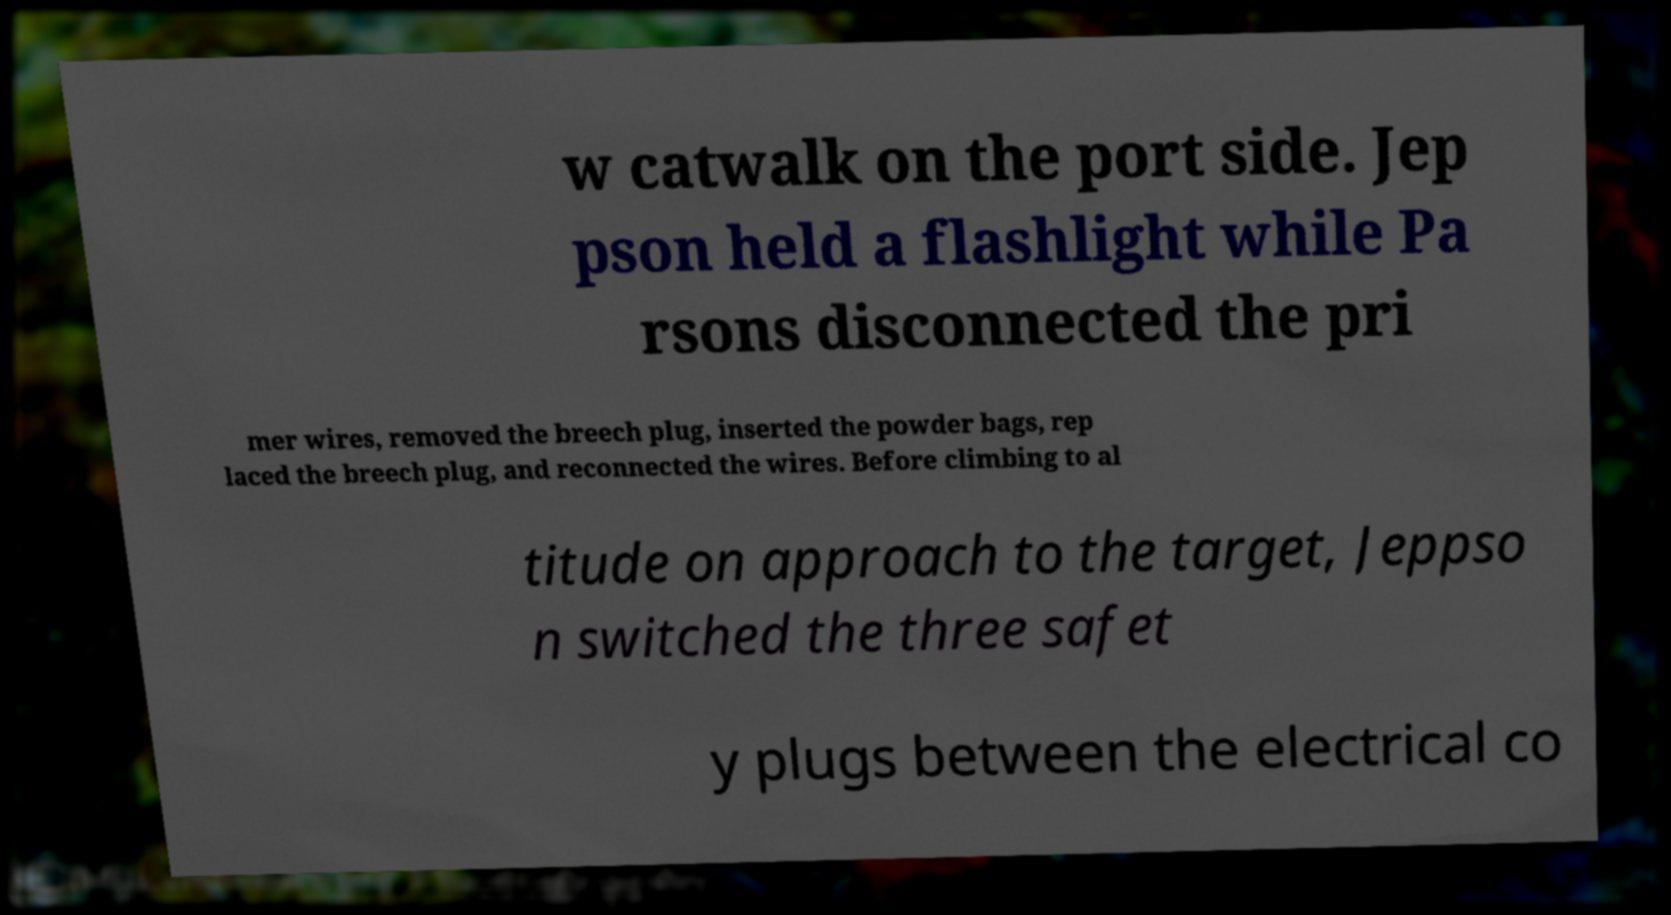Could you extract and type out the text from this image? w catwalk on the port side. Jep pson held a flashlight while Pa rsons disconnected the pri mer wires, removed the breech plug, inserted the powder bags, rep laced the breech plug, and reconnected the wires. Before climbing to al titude on approach to the target, Jeppso n switched the three safet y plugs between the electrical co 